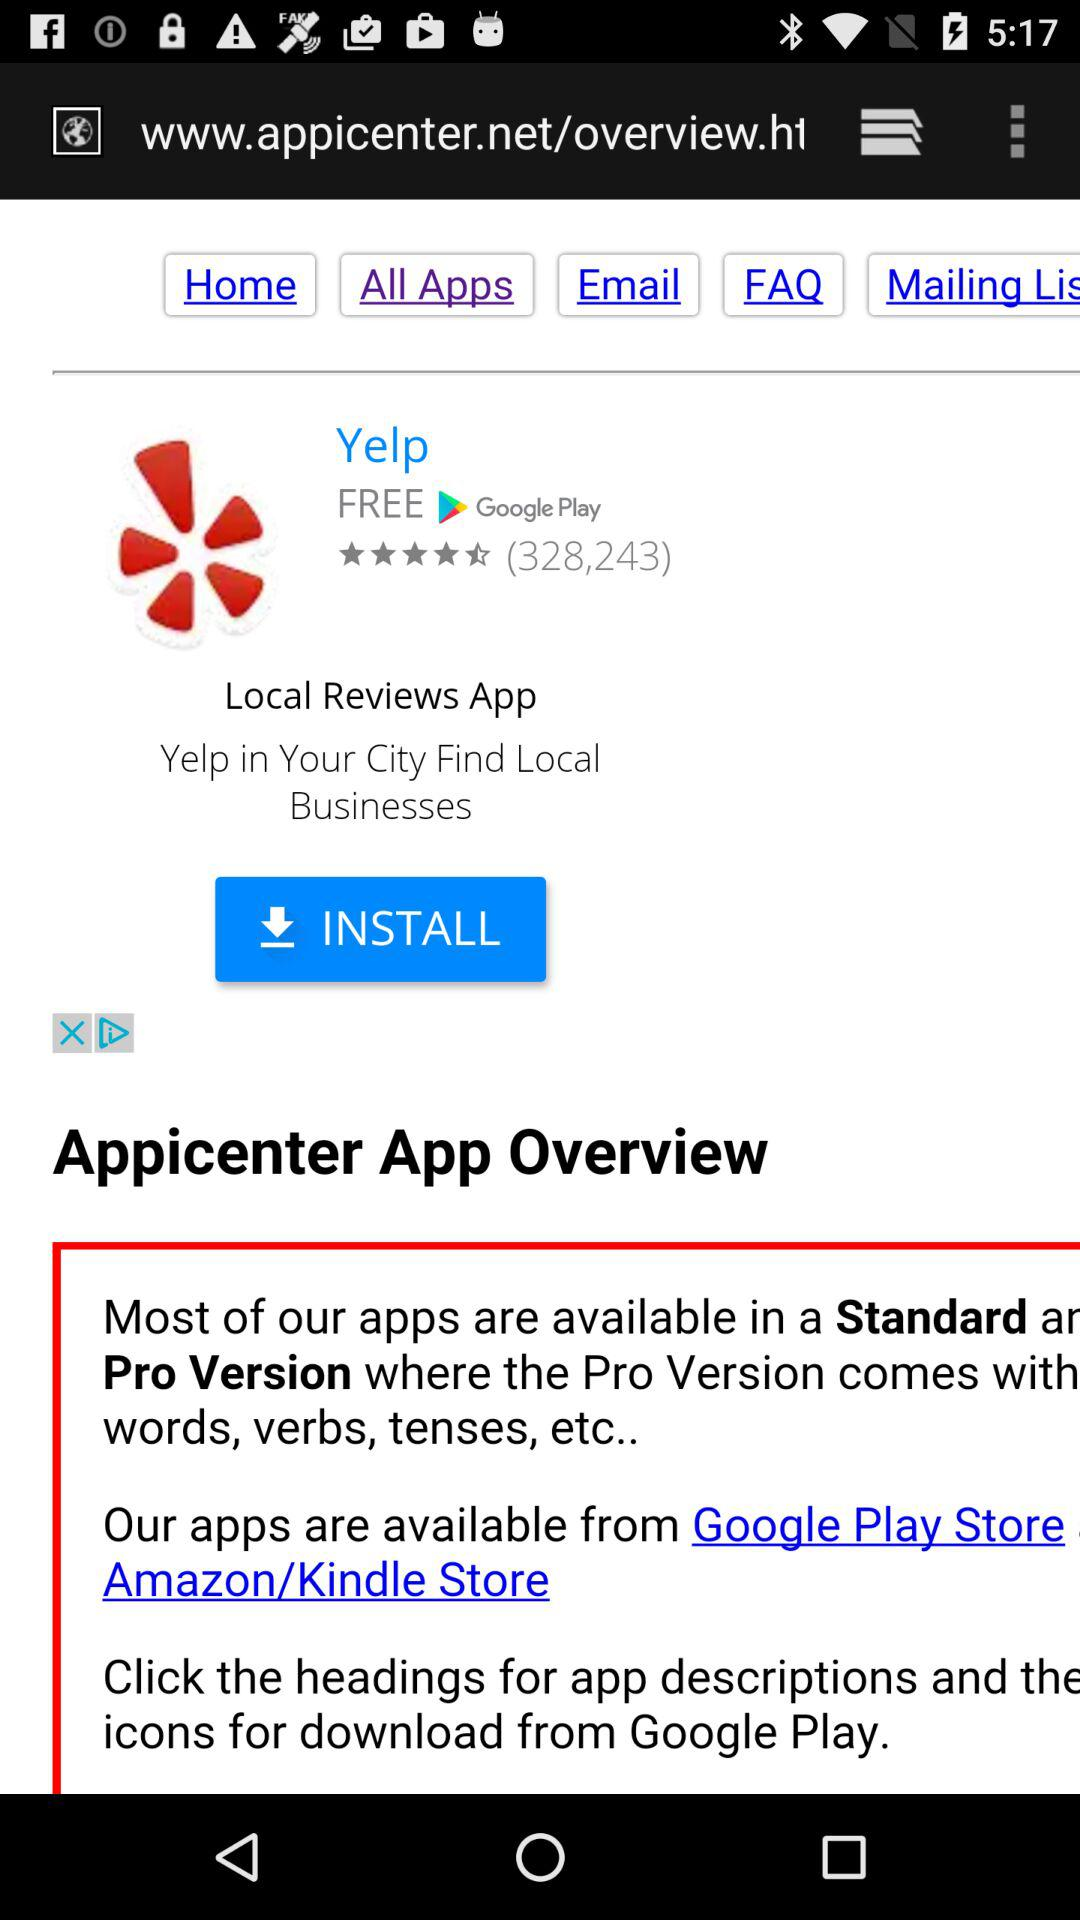How many people rated the application? There are 328,243 people who rated the application. 